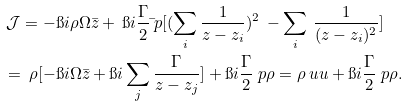<formula> <loc_0><loc_0><loc_500><loc_500>& \, \mathcal { J } = - \i i \rho \Omega \bar { z } + \, \i i \frac { \Gamma } { 2 } \bar { \ } p [ ( \sum _ { i } \frac { 1 } { z - z _ { i } } ) ^ { 2 } \, - \sum _ { i } \, \frac { 1 } { ( z - z _ { i } ) ^ { 2 } } ] \\ & = \, \rho [ - \i i \Omega \bar { z } + { \i i } \sum _ { j } \frac { \Gamma } { z - z _ { j } } ] + \i i \frac { \Gamma } { 2 } \ p \rho = \rho \ u u + \i i \frac { \Gamma } { 2 } \ p \rho .</formula> 